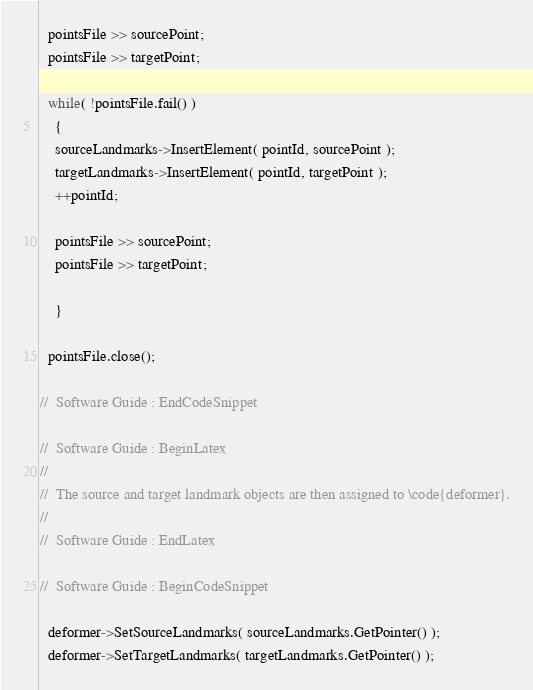<code> <loc_0><loc_0><loc_500><loc_500><_C++_>
  pointsFile >> sourcePoint;
  pointsFile >> targetPoint;

  while( !pointsFile.fail() )
    {
    sourceLandmarks->InsertElement( pointId, sourcePoint );
    targetLandmarks->InsertElement( pointId, targetPoint );
    ++pointId;

    pointsFile >> sourcePoint;
    pointsFile >> targetPoint;

    }

  pointsFile.close();

//  Software Guide : EndCodeSnippet

//  Software Guide : BeginLatex
//
//  The source and target landmark objects are then assigned to \code{deformer}.
//
//  Software Guide : EndLatex

//  Software Guide : BeginCodeSnippet

  deformer->SetSourceLandmarks( sourceLandmarks.GetPointer() );
  deformer->SetTargetLandmarks( targetLandmarks.GetPointer() );
</code> 